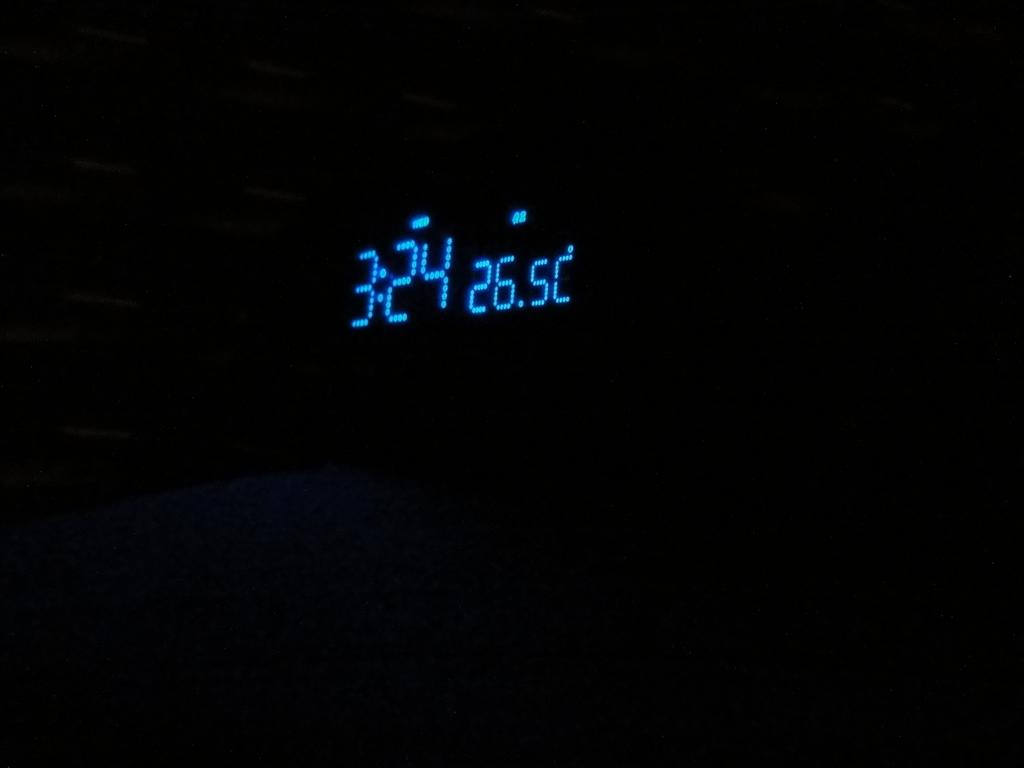<image>
Write a terse but informative summary of the picture. a blue digital display on a black background reads 26.SC 